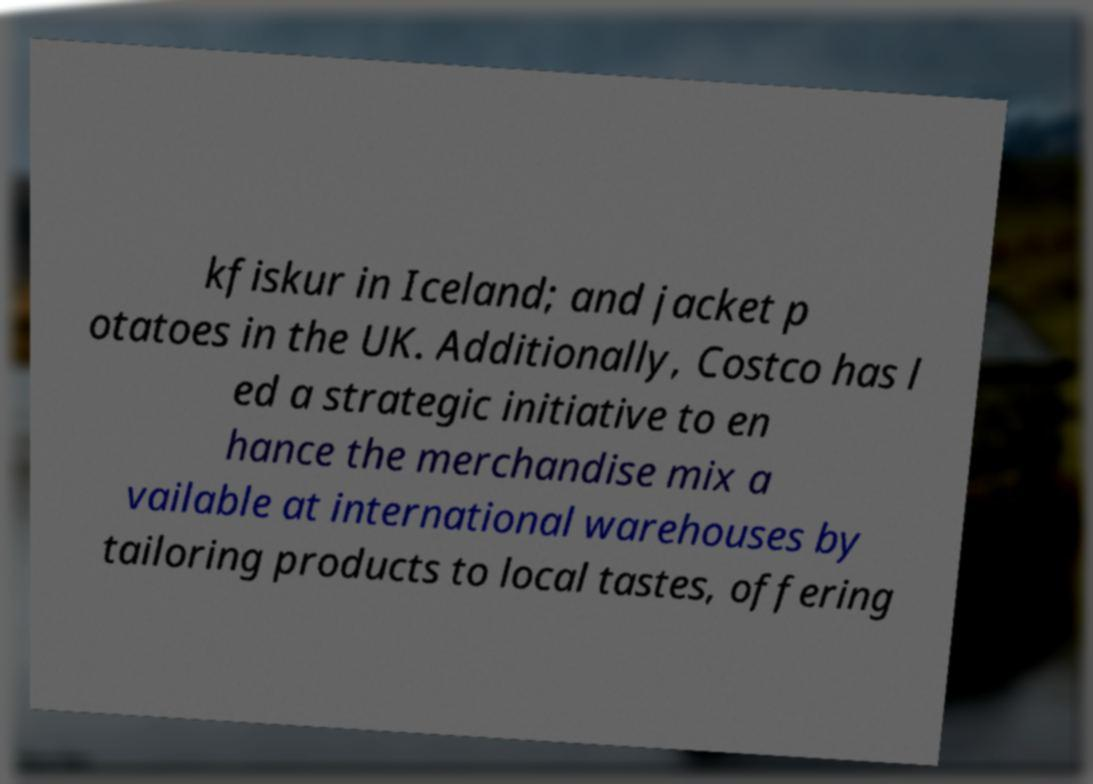Can you read and provide the text displayed in the image?This photo seems to have some interesting text. Can you extract and type it out for me? kfiskur in Iceland; and jacket p otatoes in the UK. Additionally, Costco has l ed a strategic initiative to en hance the merchandise mix a vailable at international warehouses by tailoring products to local tastes, offering 